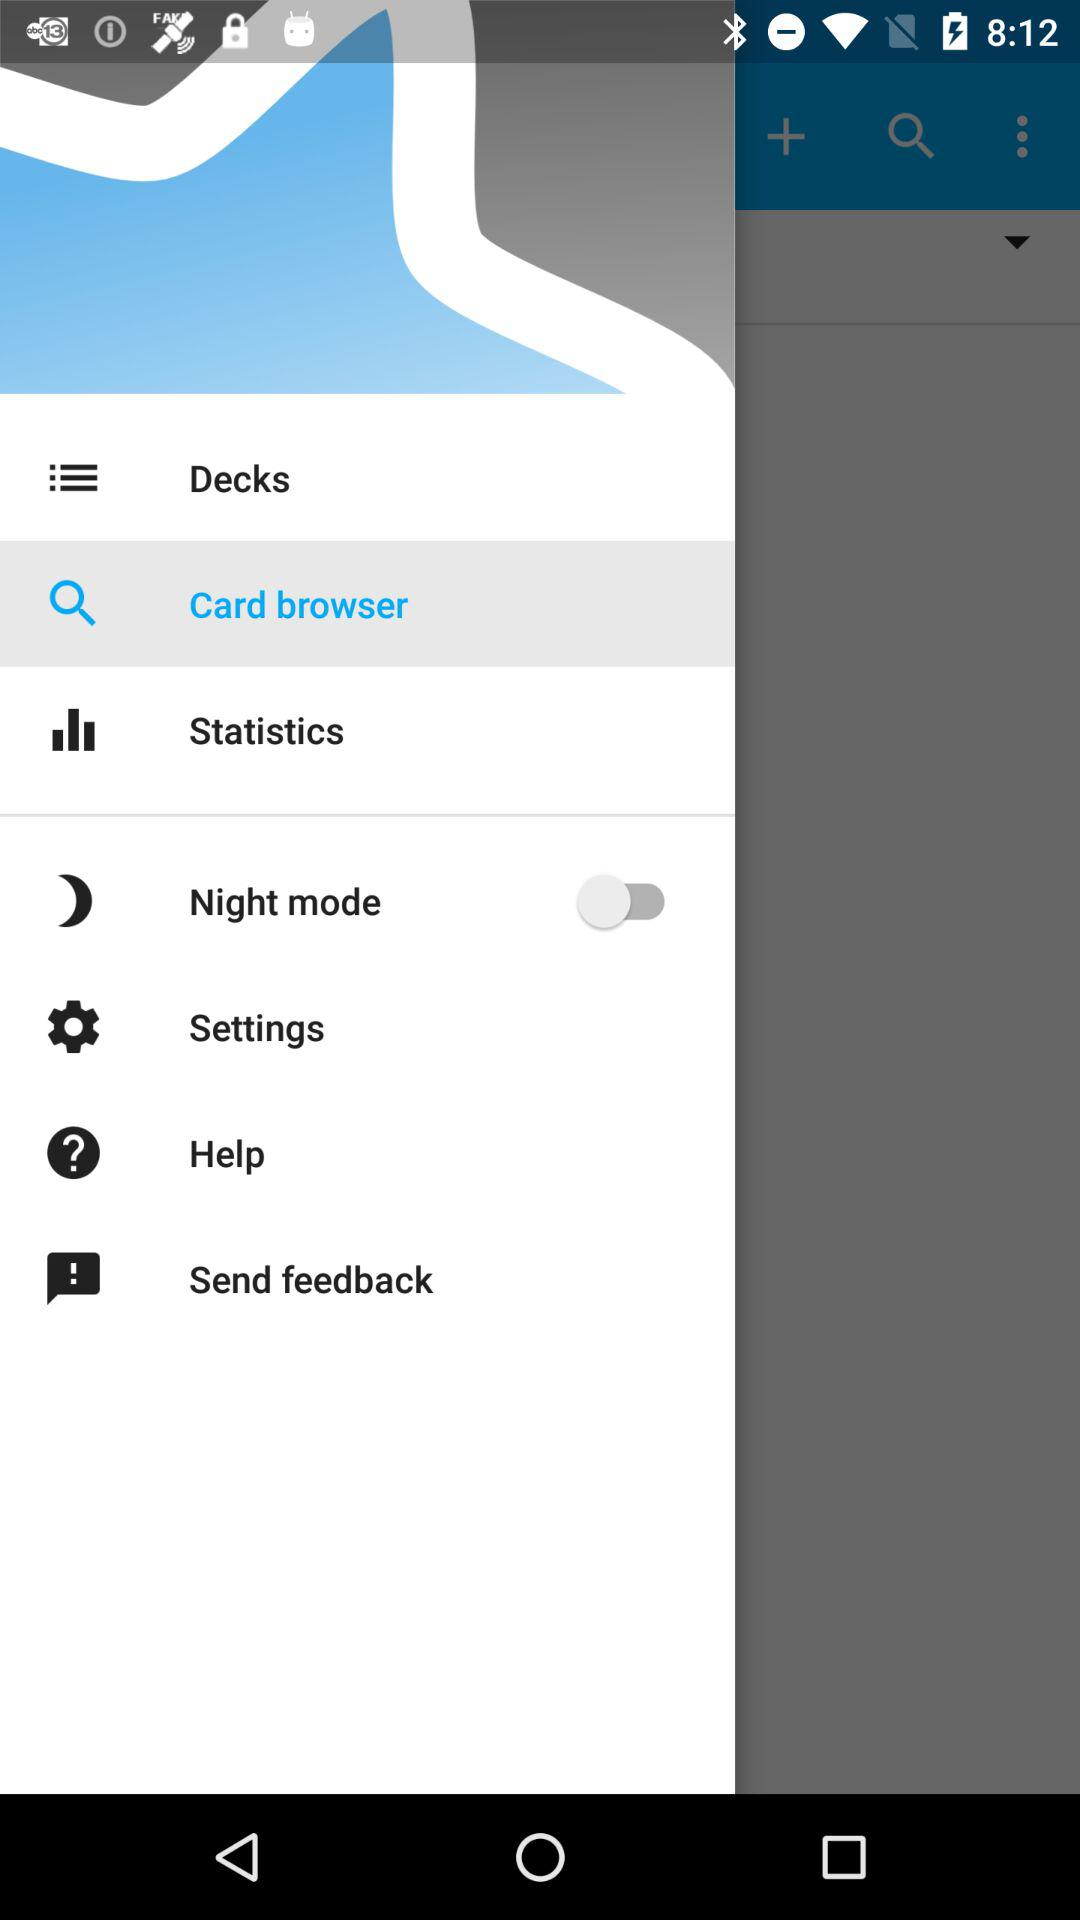What is the name of the application?
When the provided information is insufficient, respond with <no answer>. <no answer> 